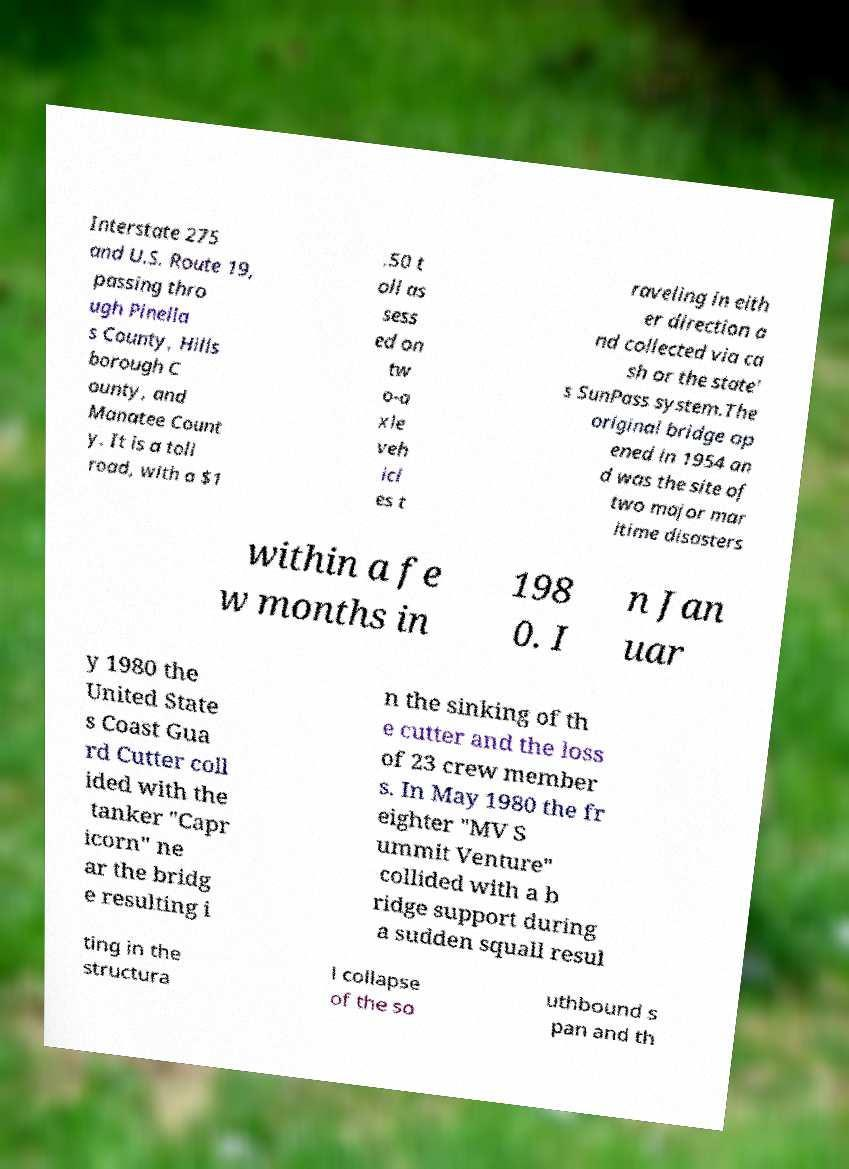Please read and relay the text visible in this image. What does it say? Interstate 275 and U.S. Route 19, passing thro ugh Pinella s County, Hills borough C ounty, and Manatee Count y. It is a toll road, with a $1 .50 t oll as sess ed on tw o-a xle veh icl es t raveling in eith er direction a nd collected via ca sh or the state' s SunPass system.The original bridge op ened in 1954 an d was the site of two major mar itime disasters within a fe w months in 198 0. I n Jan uar y 1980 the United State s Coast Gua rd Cutter coll ided with the tanker "Capr icorn" ne ar the bridg e resulting i n the sinking of th e cutter and the loss of 23 crew member s. In May 1980 the fr eighter "MV S ummit Venture" collided with a b ridge support during a sudden squall resul ting in the structura l collapse of the so uthbound s pan and th 